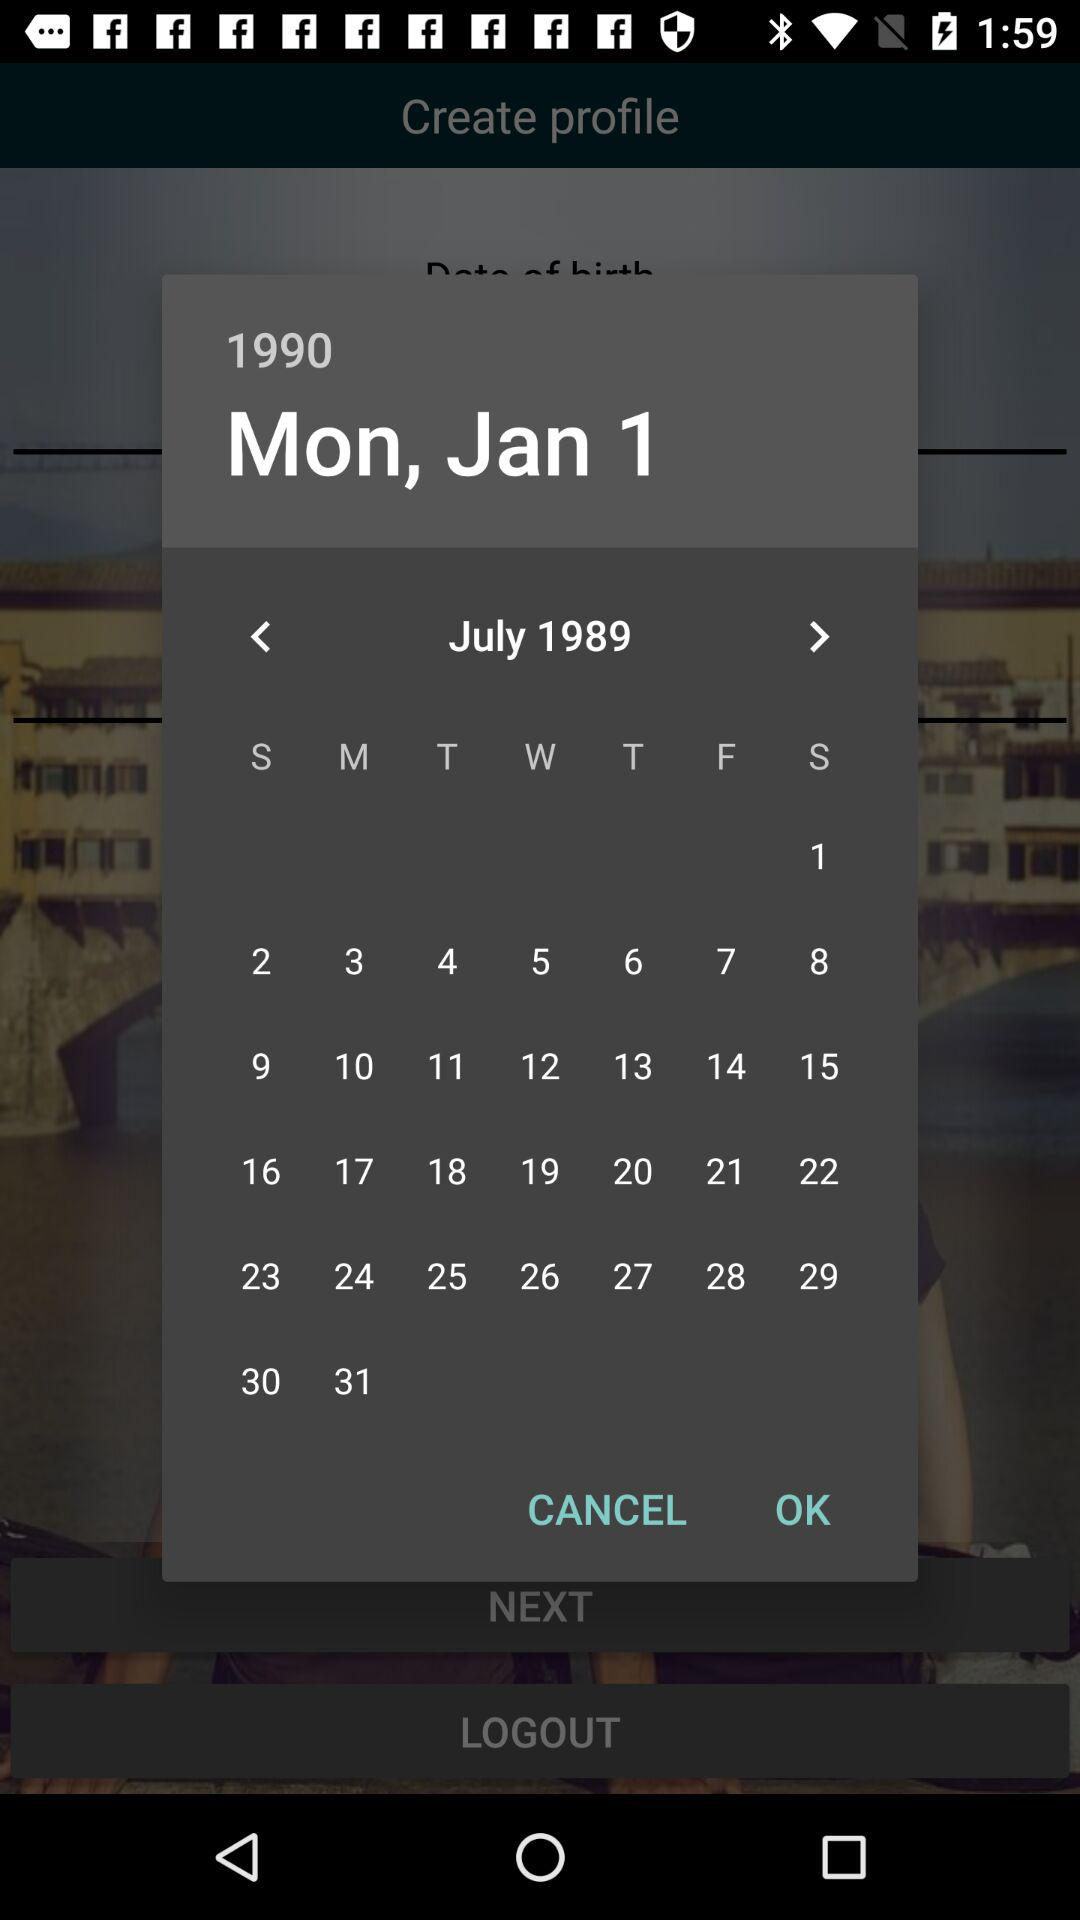Which month is selected on the calendar? The selected month is January. 